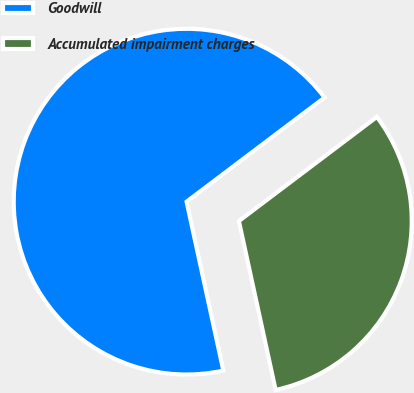Convert chart. <chart><loc_0><loc_0><loc_500><loc_500><pie_chart><fcel>Goodwill<fcel>Accumulated impairment charges<nl><fcel>68.12%<fcel>31.88%<nl></chart> 